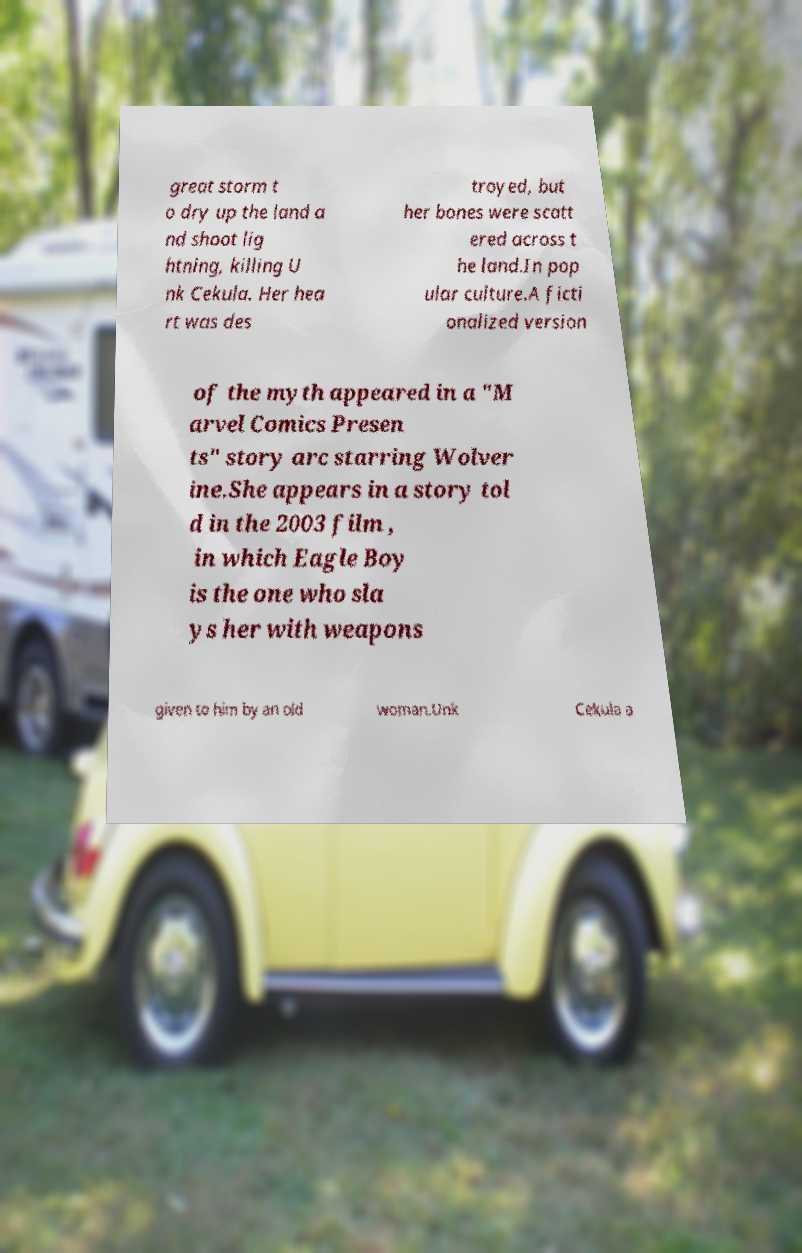I need the written content from this picture converted into text. Can you do that? great storm t o dry up the land a nd shoot lig htning, killing U nk Cekula. Her hea rt was des troyed, but her bones were scatt ered across t he land.In pop ular culture.A ficti onalized version of the myth appeared in a "M arvel Comics Presen ts" story arc starring Wolver ine.She appears in a story tol d in the 2003 film , in which Eagle Boy is the one who sla ys her with weapons given to him by an old woman.Unk Cekula a 